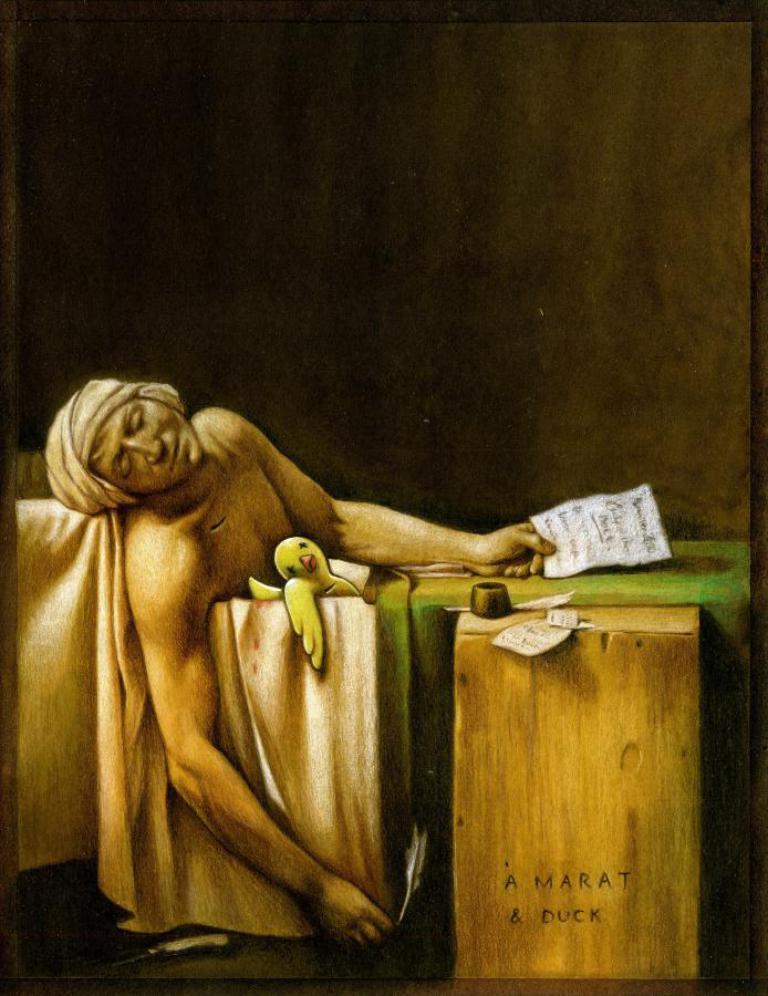Please provide a concise description of this image. The image looks like an edited image. In the center of the image we can see a person, duck, cloth in a bath tub and there are paper, desk, feathers and other objects. At the top it is dark. 